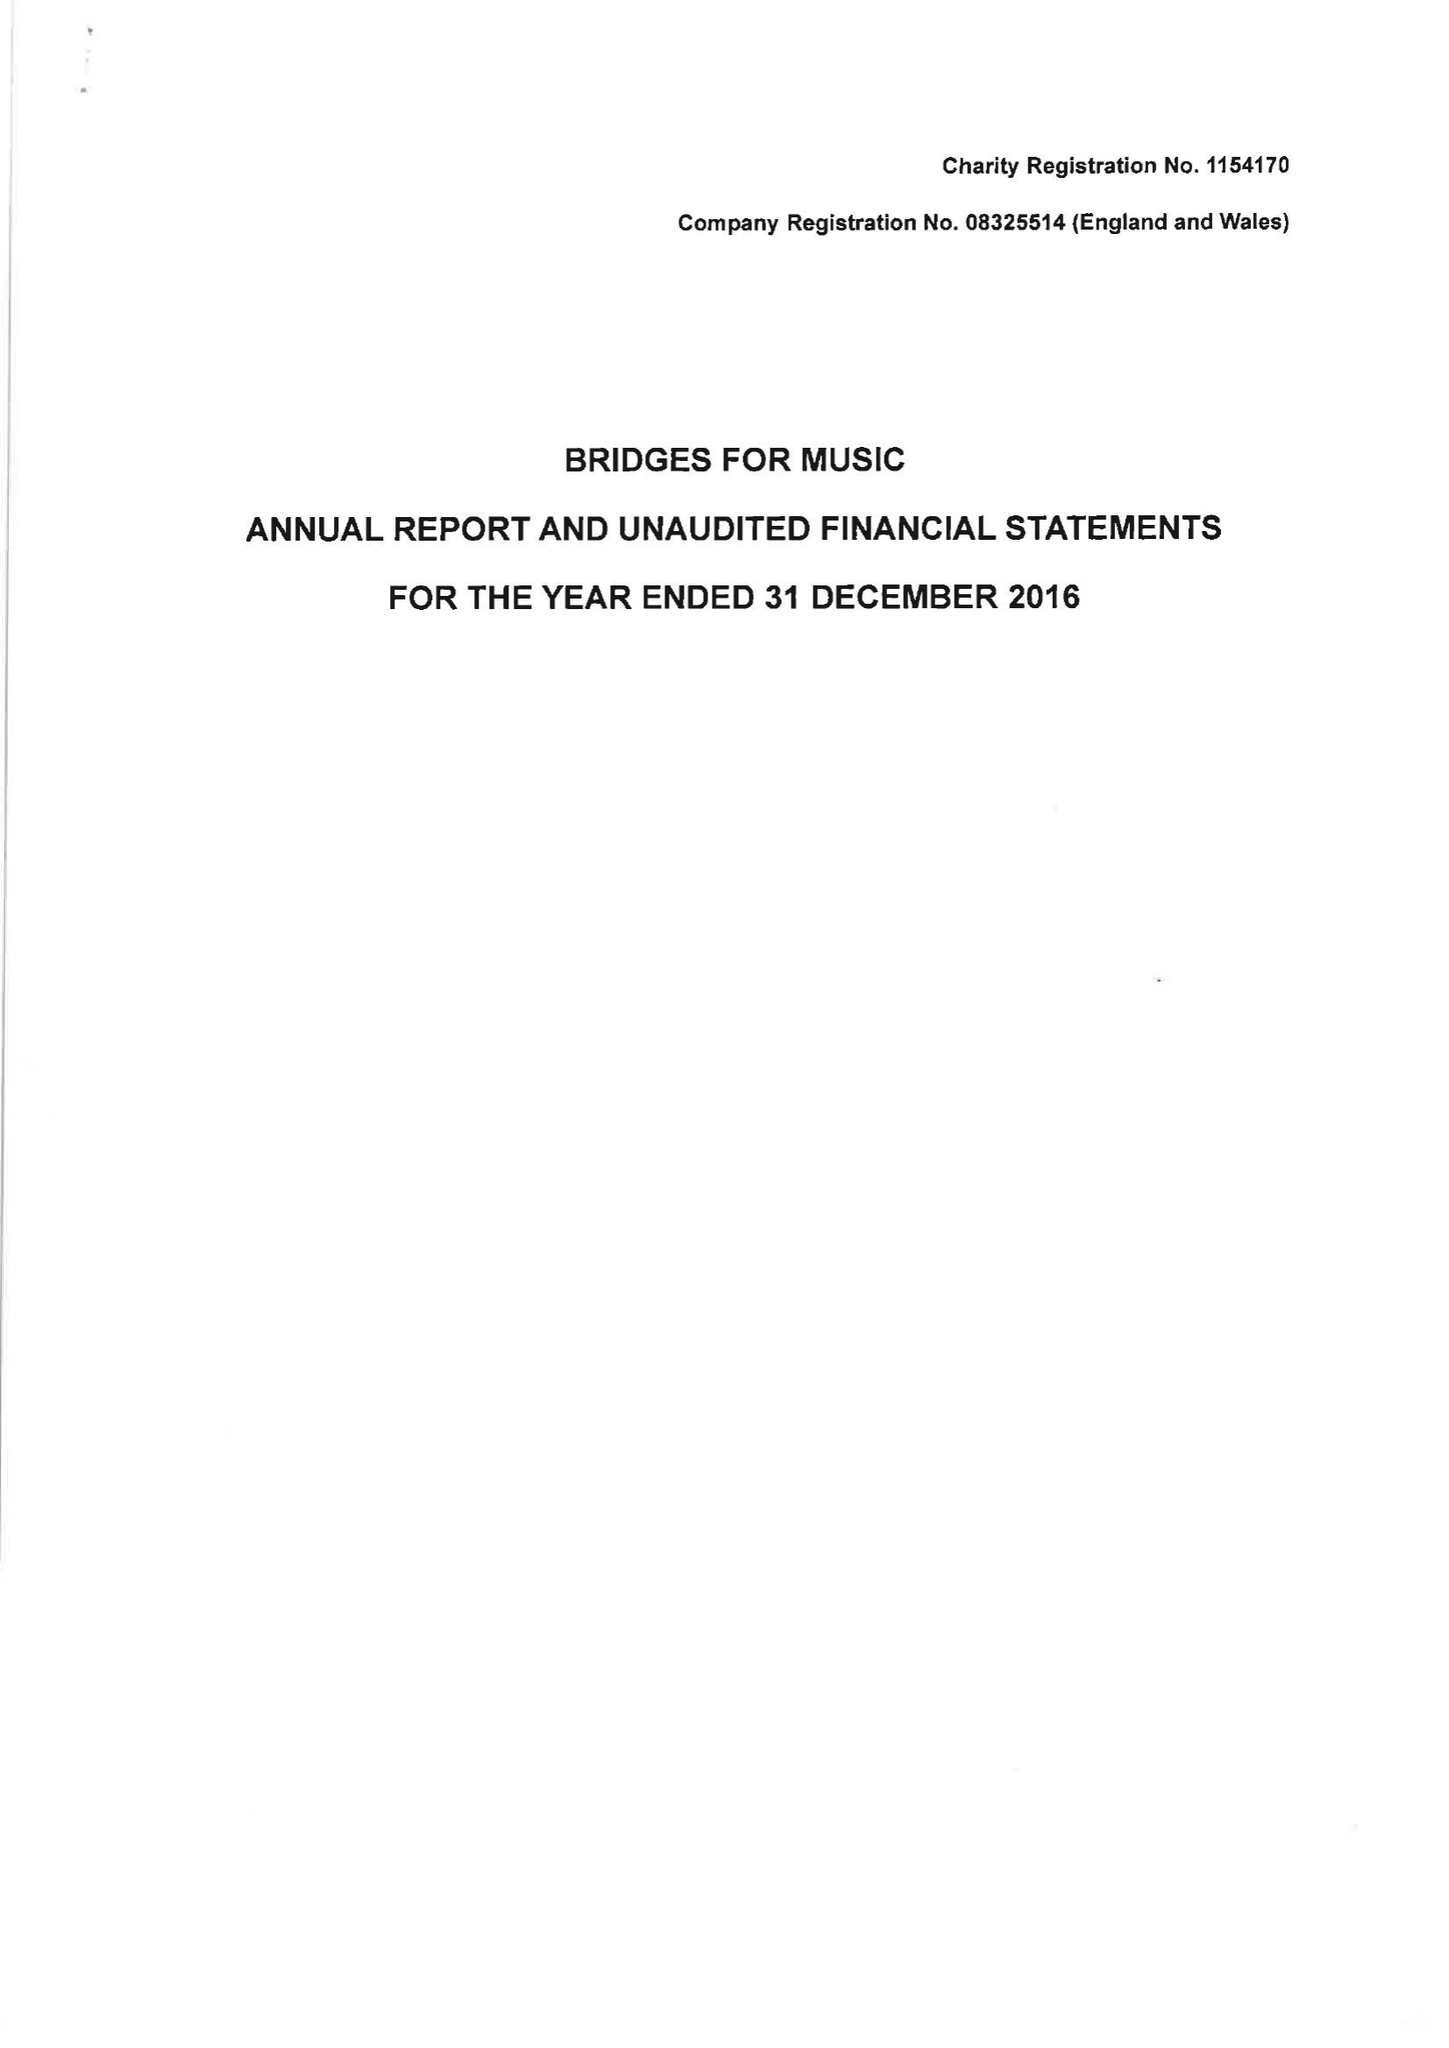What is the value for the address__street_line?
Answer the question using a single word or phrase. 8 KEAN STREET 